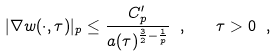Convert formula to latex. <formula><loc_0><loc_0><loc_500><loc_500>| \nabla w ( \cdot , \tau ) | _ { p } \leq \frac { C _ { p } ^ { \prime } } { a ( \tau ) ^ { \frac { 3 } { 2 } - \frac { 1 } { p } } } \ , \quad \tau > 0 \ ,</formula> 